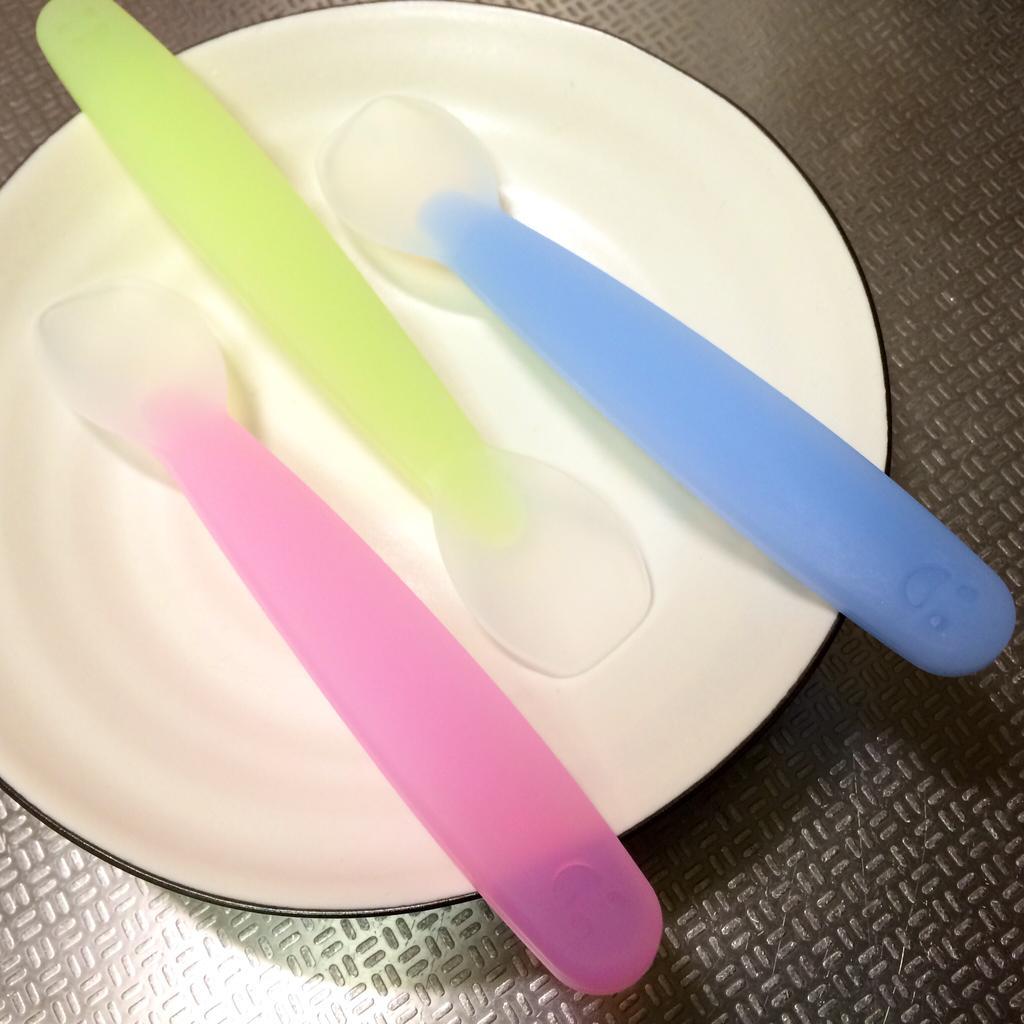How would you summarize this image in a sentence or two? In this picture there are three spoons placed on the the plate on the table. 